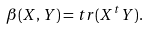Convert formula to latex. <formula><loc_0><loc_0><loc_500><loc_500>\beta ( X , Y ) = t r ( X ^ { t } Y ) .</formula> 